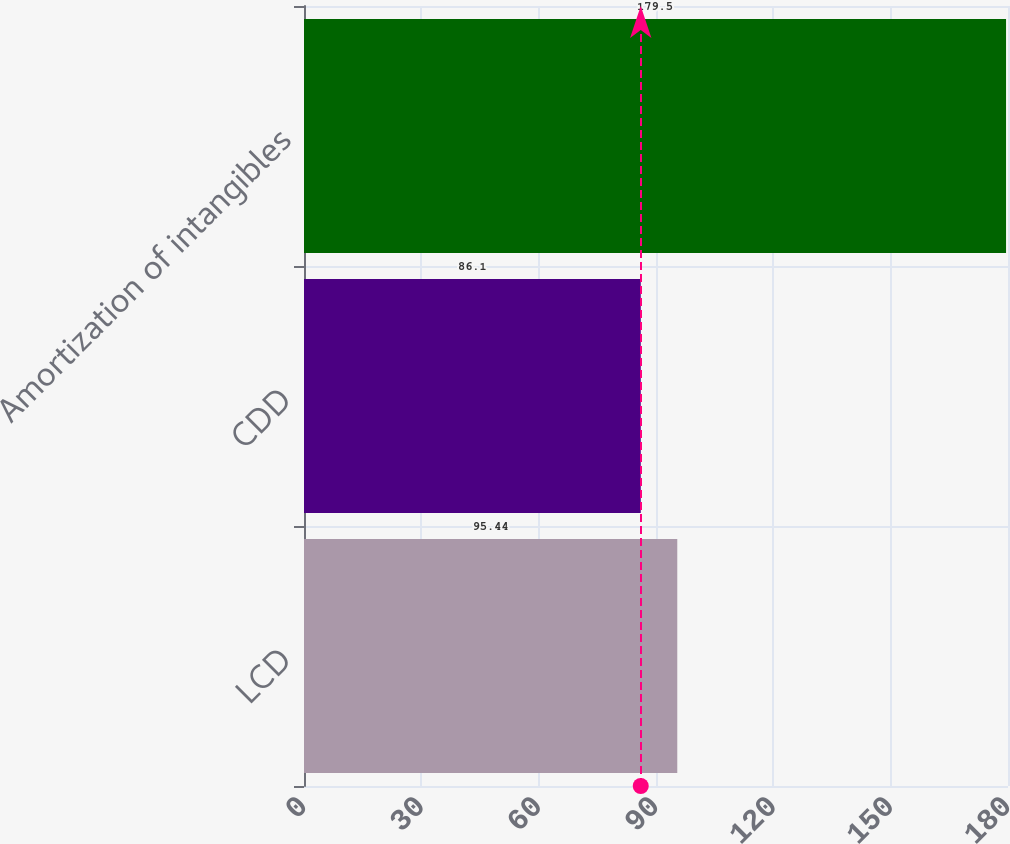<chart> <loc_0><loc_0><loc_500><loc_500><bar_chart><fcel>LCD<fcel>CDD<fcel>Amortization of intangibles<nl><fcel>95.44<fcel>86.1<fcel>179.5<nl></chart> 